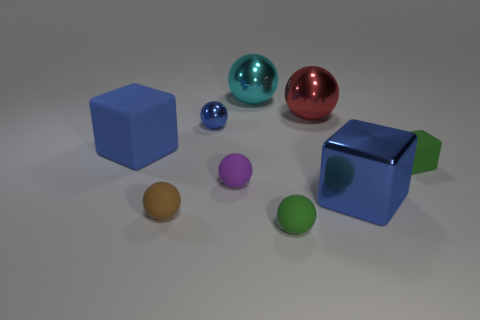How many things are either large blue matte cubes or rubber things that are to the left of the cyan shiny object?
Give a very brief answer. 3. There is a matte thing that is to the right of the green rubber object left of the big blue metal cube; how many small blue balls are to the left of it?
Offer a terse response. 1. Does the big thing to the left of the tiny metal sphere have the same shape as the cyan shiny thing?
Make the answer very short. No. Are there any objects to the left of the metallic sphere that is left of the cyan ball?
Your response must be concise. Yes. What number of blue metal cubes are there?
Give a very brief answer. 1. There is a tiny object that is both in front of the blue rubber block and behind the purple sphere; what is its color?
Provide a short and direct response. Green. There is a blue metallic object that is the same shape as the purple rubber object; what size is it?
Your response must be concise. Small. How many purple metal cylinders are the same size as the red metallic sphere?
Your answer should be compact. 0. What is the material of the cyan object?
Keep it short and to the point. Metal. Are there any large blue blocks behind the big red metal ball?
Offer a terse response. No. 